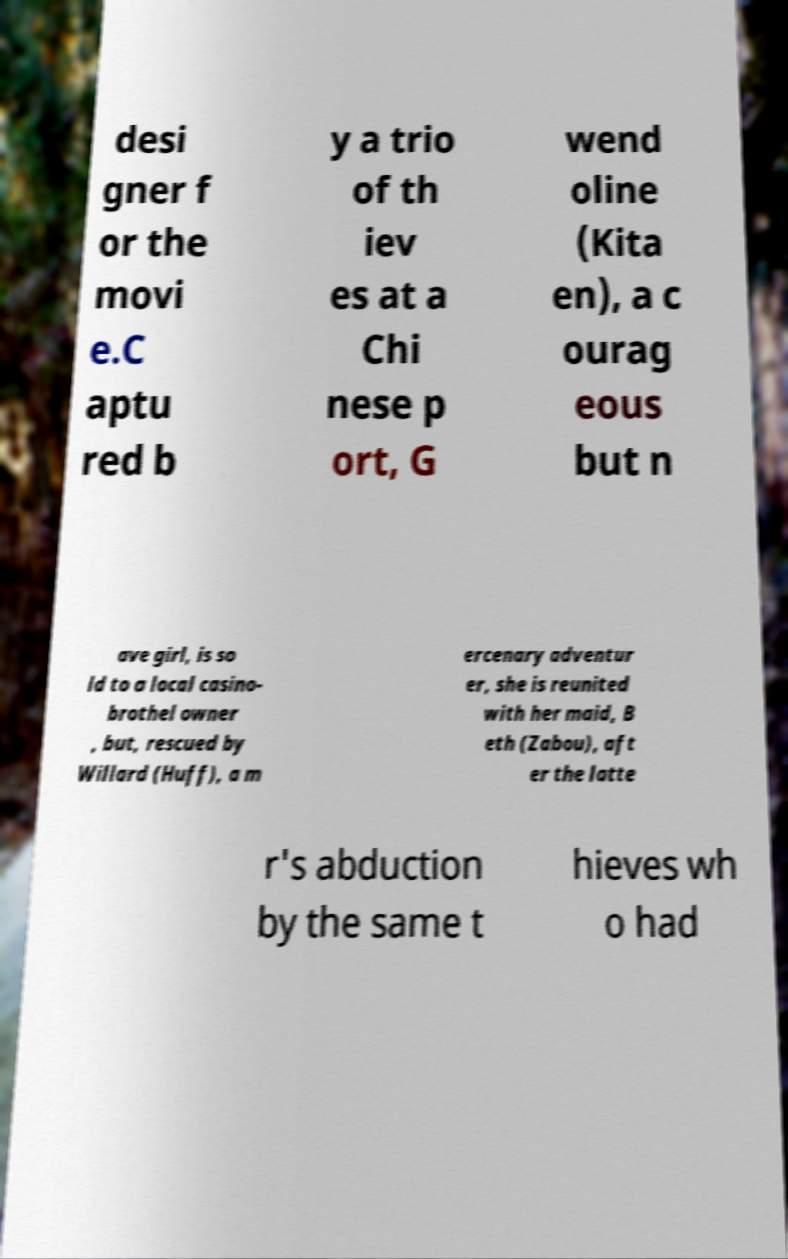Could you assist in decoding the text presented in this image and type it out clearly? desi gner f or the movi e.C aptu red b y a trio of th iev es at a Chi nese p ort, G wend oline (Kita en), a c ourag eous but n ave girl, is so ld to a local casino- brothel owner , but, rescued by Willard (Huff), a m ercenary adventur er, she is reunited with her maid, B eth (Zabou), aft er the latte r's abduction by the same t hieves wh o had 